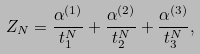<formula> <loc_0><loc_0><loc_500><loc_500>Z _ { N } = \frac { \alpha ^ { ( 1 ) } } { t _ { 1 } ^ { N } } + \frac { \alpha ^ { ( 2 ) } } { t _ { 2 } ^ { N } } + \frac { \alpha ^ { ( 3 ) } } { t _ { 3 } ^ { N } } ,</formula> 